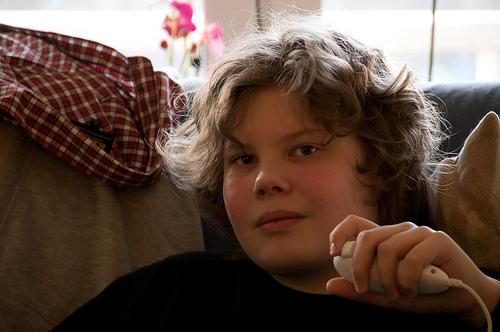What color is the flower in the background?
Answer briefly. Pink. Why is the girl smiling?
Short answer required. She's happy. What color is her hair?
Write a very short answer. Brown. What color is it?
Answer briefly. White. What color is the pillow behind his head?
Quick response, please. Brown. Is this person standing?
Give a very brief answer. No. Is this a male or female child?
Concise answer only. Male. What color is the remote control?
Keep it brief. White. Where is this?
Be succinct. Living room. Is this a black and white picture?
Be succinct. No. Is she talking to someone?
Be succinct. No. Is the boy wearing plaid?
Give a very brief answer. No. 